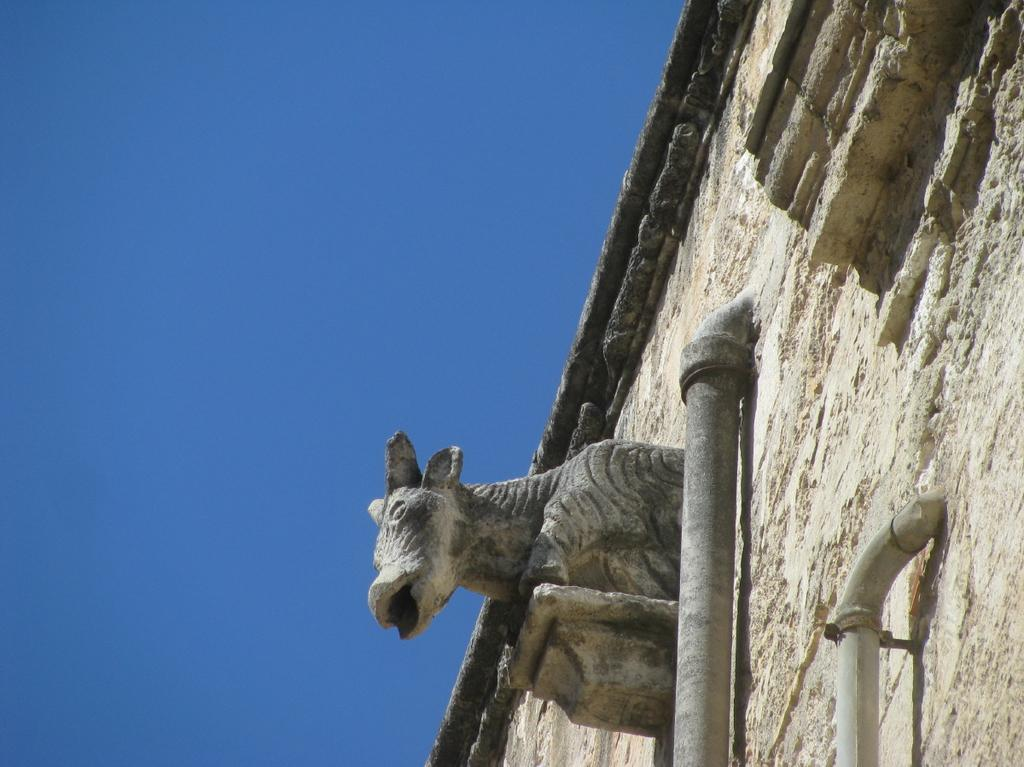What is the main subject in the image? There is a statue in the image. What else can be seen in the image besides the statue? There is a wall and a pipeline visible in the image. What is visible in the background of the image? The sky is visible in the image. How many cakes are on the calculator in the image? There is no calculator or cake present in the image. 